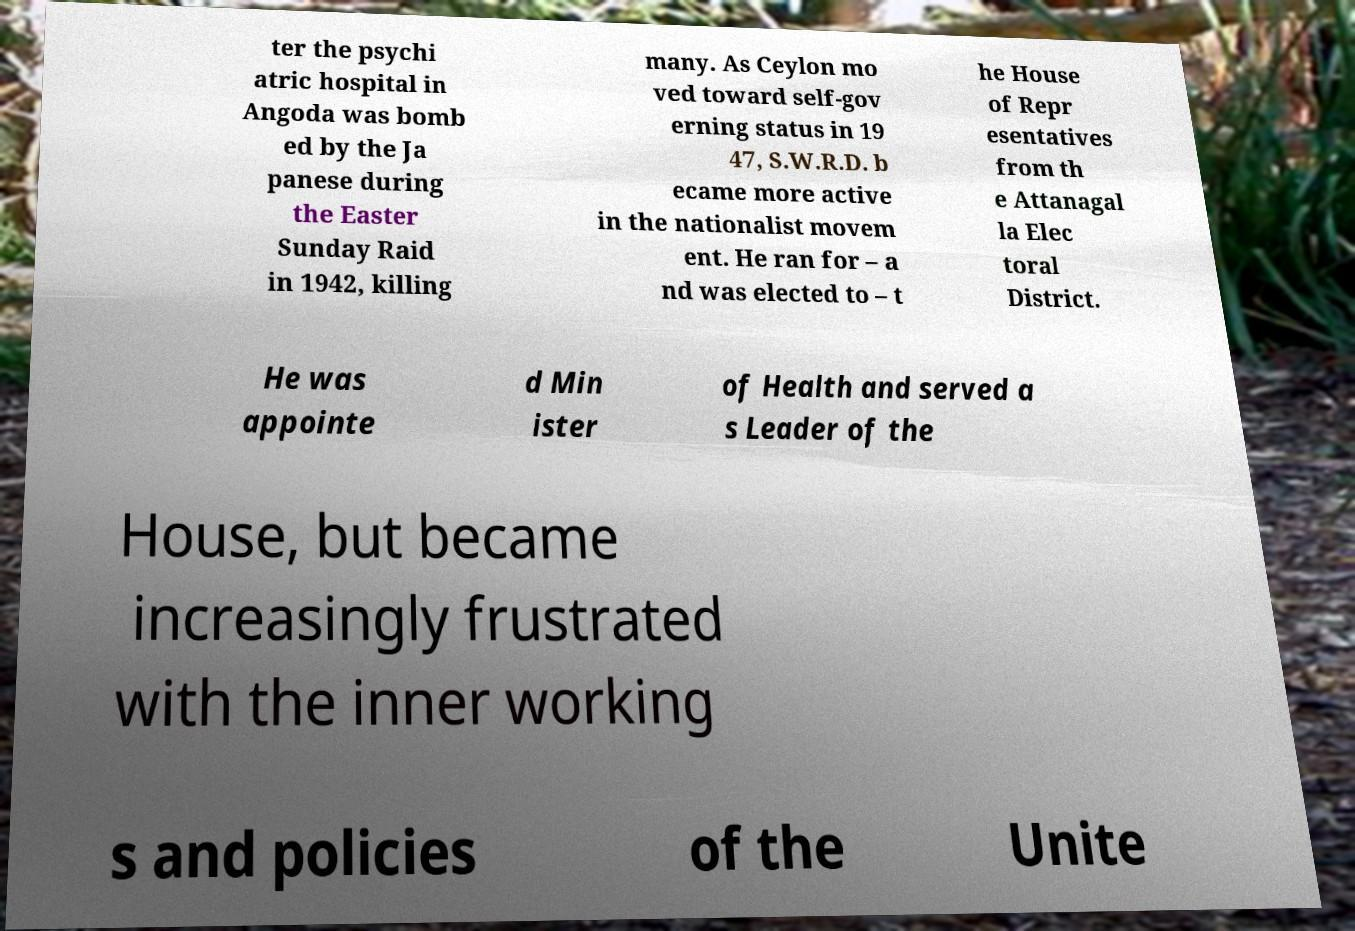Please read and relay the text visible in this image. What does it say? ter the psychi atric hospital in Angoda was bomb ed by the Ja panese during the Easter Sunday Raid in 1942, killing many. As Ceylon mo ved toward self-gov erning status in 19 47, S.W.R.D. b ecame more active in the nationalist movem ent. He ran for – a nd was elected to – t he House of Repr esentatives from th e Attanagal la Elec toral District. He was appointe d Min ister of Health and served a s Leader of the House, but became increasingly frustrated with the inner working s and policies of the Unite 